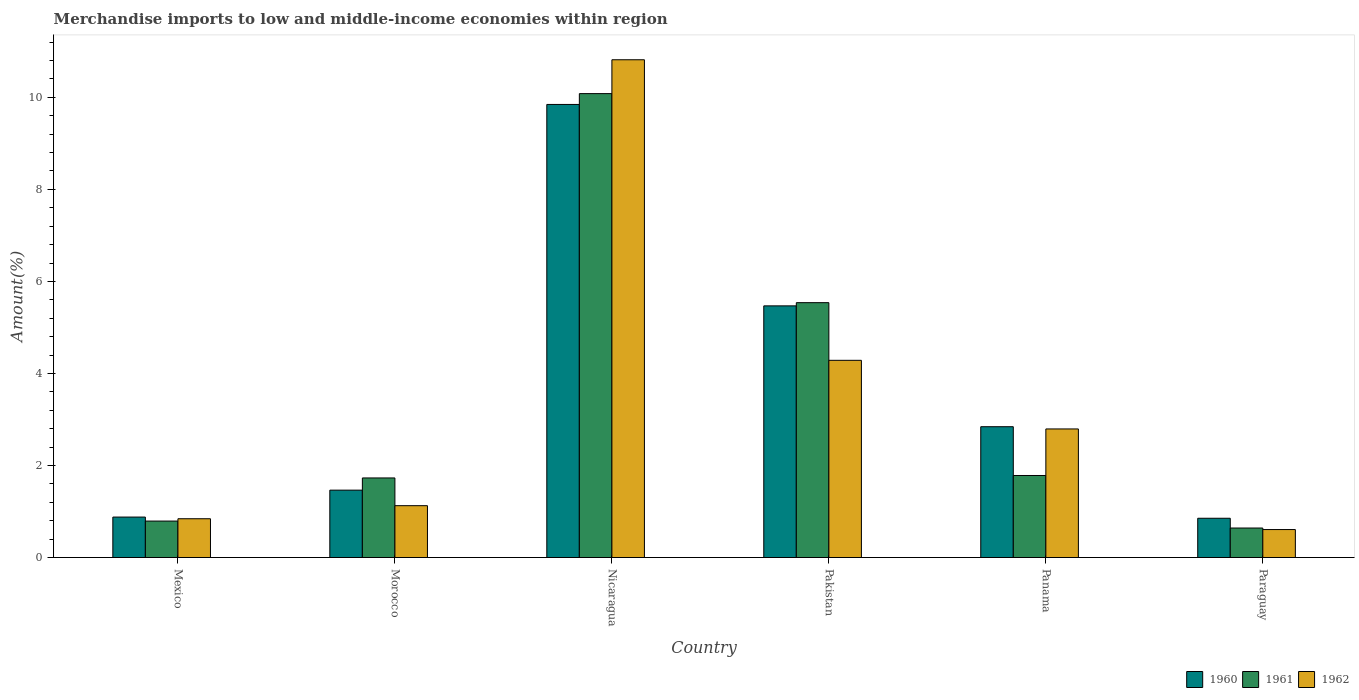How many groups of bars are there?
Provide a succinct answer. 6. Are the number of bars per tick equal to the number of legend labels?
Keep it short and to the point. Yes. How many bars are there on the 3rd tick from the right?
Your answer should be very brief. 3. What is the label of the 5th group of bars from the left?
Keep it short and to the point. Panama. What is the percentage of amount earned from merchandise imports in 1961 in Paraguay?
Your response must be concise. 0.64. Across all countries, what is the maximum percentage of amount earned from merchandise imports in 1960?
Your response must be concise. 9.85. Across all countries, what is the minimum percentage of amount earned from merchandise imports in 1960?
Give a very brief answer. 0.85. In which country was the percentage of amount earned from merchandise imports in 1960 maximum?
Your answer should be very brief. Nicaragua. In which country was the percentage of amount earned from merchandise imports in 1961 minimum?
Provide a short and direct response. Paraguay. What is the total percentage of amount earned from merchandise imports in 1962 in the graph?
Ensure brevity in your answer.  20.47. What is the difference between the percentage of amount earned from merchandise imports in 1962 in Mexico and that in Morocco?
Your answer should be very brief. -0.28. What is the difference between the percentage of amount earned from merchandise imports in 1962 in Morocco and the percentage of amount earned from merchandise imports in 1960 in Pakistan?
Your response must be concise. -4.34. What is the average percentage of amount earned from merchandise imports in 1961 per country?
Provide a succinct answer. 3.43. What is the difference between the percentage of amount earned from merchandise imports of/in 1962 and percentage of amount earned from merchandise imports of/in 1960 in Mexico?
Ensure brevity in your answer.  -0.04. What is the ratio of the percentage of amount earned from merchandise imports in 1960 in Mexico to that in Morocco?
Make the answer very short. 0.6. Is the percentage of amount earned from merchandise imports in 1961 in Nicaragua less than that in Paraguay?
Offer a terse response. No. What is the difference between the highest and the second highest percentage of amount earned from merchandise imports in 1961?
Ensure brevity in your answer.  -8.3. What is the difference between the highest and the lowest percentage of amount earned from merchandise imports in 1961?
Provide a succinct answer. 9.44. Is the sum of the percentage of amount earned from merchandise imports in 1962 in Mexico and Pakistan greater than the maximum percentage of amount earned from merchandise imports in 1961 across all countries?
Provide a short and direct response. No. What does the 3rd bar from the right in Mexico represents?
Make the answer very short. 1960. Are all the bars in the graph horizontal?
Provide a short and direct response. No. How many countries are there in the graph?
Your answer should be compact. 6. What is the difference between two consecutive major ticks on the Y-axis?
Make the answer very short. 2. Are the values on the major ticks of Y-axis written in scientific E-notation?
Keep it short and to the point. No. Does the graph contain grids?
Offer a terse response. No. How are the legend labels stacked?
Offer a very short reply. Horizontal. What is the title of the graph?
Your answer should be very brief. Merchandise imports to low and middle-income economies within region. Does "1967" appear as one of the legend labels in the graph?
Keep it short and to the point. No. What is the label or title of the Y-axis?
Offer a very short reply. Amount(%). What is the Amount(%) of 1960 in Mexico?
Your answer should be very brief. 0.88. What is the Amount(%) in 1961 in Mexico?
Make the answer very short. 0.79. What is the Amount(%) in 1962 in Mexico?
Make the answer very short. 0.84. What is the Amount(%) of 1960 in Morocco?
Make the answer very short. 1.46. What is the Amount(%) in 1961 in Morocco?
Provide a succinct answer. 1.73. What is the Amount(%) in 1962 in Morocco?
Offer a very short reply. 1.13. What is the Amount(%) of 1960 in Nicaragua?
Provide a short and direct response. 9.85. What is the Amount(%) in 1961 in Nicaragua?
Your response must be concise. 10.08. What is the Amount(%) in 1962 in Nicaragua?
Ensure brevity in your answer.  10.82. What is the Amount(%) in 1960 in Pakistan?
Your answer should be compact. 5.47. What is the Amount(%) in 1961 in Pakistan?
Your answer should be very brief. 5.54. What is the Amount(%) of 1962 in Pakistan?
Your answer should be very brief. 4.29. What is the Amount(%) in 1960 in Panama?
Offer a terse response. 2.84. What is the Amount(%) in 1961 in Panama?
Ensure brevity in your answer.  1.78. What is the Amount(%) of 1962 in Panama?
Ensure brevity in your answer.  2.79. What is the Amount(%) in 1960 in Paraguay?
Your answer should be compact. 0.85. What is the Amount(%) of 1961 in Paraguay?
Provide a short and direct response. 0.64. What is the Amount(%) in 1962 in Paraguay?
Your answer should be very brief. 0.61. Across all countries, what is the maximum Amount(%) of 1960?
Provide a short and direct response. 9.85. Across all countries, what is the maximum Amount(%) of 1961?
Provide a short and direct response. 10.08. Across all countries, what is the maximum Amount(%) of 1962?
Your response must be concise. 10.82. Across all countries, what is the minimum Amount(%) in 1960?
Keep it short and to the point. 0.85. Across all countries, what is the minimum Amount(%) in 1961?
Provide a succinct answer. 0.64. Across all countries, what is the minimum Amount(%) of 1962?
Give a very brief answer. 0.61. What is the total Amount(%) in 1960 in the graph?
Offer a terse response. 21.35. What is the total Amount(%) in 1961 in the graph?
Make the answer very short. 20.56. What is the total Amount(%) of 1962 in the graph?
Keep it short and to the point. 20.47. What is the difference between the Amount(%) in 1960 in Mexico and that in Morocco?
Keep it short and to the point. -0.59. What is the difference between the Amount(%) of 1961 in Mexico and that in Morocco?
Your answer should be very brief. -0.94. What is the difference between the Amount(%) in 1962 in Mexico and that in Morocco?
Give a very brief answer. -0.28. What is the difference between the Amount(%) of 1960 in Mexico and that in Nicaragua?
Offer a terse response. -8.97. What is the difference between the Amount(%) in 1961 in Mexico and that in Nicaragua?
Make the answer very short. -9.29. What is the difference between the Amount(%) of 1962 in Mexico and that in Nicaragua?
Your response must be concise. -9.97. What is the difference between the Amount(%) in 1960 in Mexico and that in Pakistan?
Ensure brevity in your answer.  -4.59. What is the difference between the Amount(%) in 1961 in Mexico and that in Pakistan?
Your answer should be very brief. -4.75. What is the difference between the Amount(%) of 1962 in Mexico and that in Pakistan?
Offer a very short reply. -3.44. What is the difference between the Amount(%) in 1960 in Mexico and that in Panama?
Offer a very short reply. -1.96. What is the difference between the Amount(%) in 1961 in Mexico and that in Panama?
Ensure brevity in your answer.  -0.99. What is the difference between the Amount(%) of 1962 in Mexico and that in Panama?
Provide a short and direct response. -1.95. What is the difference between the Amount(%) of 1960 in Mexico and that in Paraguay?
Keep it short and to the point. 0.03. What is the difference between the Amount(%) of 1961 in Mexico and that in Paraguay?
Your answer should be very brief. 0.15. What is the difference between the Amount(%) in 1962 in Mexico and that in Paraguay?
Provide a short and direct response. 0.23. What is the difference between the Amount(%) of 1960 in Morocco and that in Nicaragua?
Keep it short and to the point. -8.38. What is the difference between the Amount(%) of 1961 in Morocco and that in Nicaragua?
Give a very brief answer. -8.35. What is the difference between the Amount(%) in 1962 in Morocco and that in Nicaragua?
Provide a succinct answer. -9.69. What is the difference between the Amount(%) of 1960 in Morocco and that in Pakistan?
Offer a terse response. -4. What is the difference between the Amount(%) in 1961 in Morocco and that in Pakistan?
Your response must be concise. -3.81. What is the difference between the Amount(%) of 1962 in Morocco and that in Pakistan?
Provide a succinct answer. -3.16. What is the difference between the Amount(%) in 1960 in Morocco and that in Panama?
Offer a very short reply. -1.38. What is the difference between the Amount(%) of 1961 in Morocco and that in Panama?
Offer a terse response. -0.05. What is the difference between the Amount(%) in 1962 in Morocco and that in Panama?
Make the answer very short. -1.67. What is the difference between the Amount(%) in 1960 in Morocco and that in Paraguay?
Give a very brief answer. 0.61. What is the difference between the Amount(%) of 1961 in Morocco and that in Paraguay?
Your answer should be very brief. 1.09. What is the difference between the Amount(%) in 1962 in Morocco and that in Paraguay?
Your answer should be very brief. 0.52. What is the difference between the Amount(%) of 1960 in Nicaragua and that in Pakistan?
Keep it short and to the point. 4.38. What is the difference between the Amount(%) in 1961 in Nicaragua and that in Pakistan?
Give a very brief answer. 4.54. What is the difference between the Amount(%) in 1962 in Nicaragua and that in Pakistan?
Offer a terse response. 6.53. What is the difference between the Amount(%) in 1960 in Nicaragua and that in Panama?
Your answer should be very brief. 7. What is the difference between the Amount(%) in 1961 in Nicaragua and that in Panama?
Keep it short and to the point. 8.3. What is the difference between the Amount(%) of 1962 in Nicaragua and that in Panama?
Provide a short and direct response. 8.02. What is the difference between the Amount(%) in 1960 in Nicaragua and that in Paraguay?
Provide a short and direct response. 8.99. What is the difference between the Amount(%) in 1961 in Nicaragua and that in Paraguay?
Make the answer very short. 9.44. What is the difference between the Amount(%) in 1962 in Nicaragua and that in Paraguay?
Give a very brief answer. 10.21. What is the difference between the Amount(%) of 1960 in Pakistan and that in Panama?
Provide a short and direct response. 2.63. What is the difference between the Amount(%) of 1961 in Pakistan and that in Panama?
Your answer should be very brief. 3.76. What is the difference between the Amount(%) in 1962 in Pakistan and that in Panama?
Your response must be concise. 1.49. What is the difference between the Amount(%) in 1960 in Pakistan and that in Paraguay?
Your answer should be very brief. 4.62. What is the difference between the Amount(%) of 1961 in Pakistan and that in Paraguay?
Provide a succinct answer. 4.9. What is the difference between the Amount(%) of 1962 in Pakistan and that in Paraguay?
Keep it short and to the point. 3.68. What is the difference between the Amount(%) of 1960 in Panama and that in Paraguay?
Keep it short and to the point. 1.99. What is the difference between the Amount(%) in 1961 in Panama and that in Paraguay?
Keep it short and to the point. 1.14. What is the difference between the Amount(%) of 1962 in Panama and that in Paraguay?
Provide a succinct answer. 2.19. What is the difference between the Amount(%) of 1960 in Mexico and the Amount(%) of 1961 in Morocco?
Your answer should be compact. -0.85. What is the difference between the Amount(%) of 1960 in Mexico and the Amount(%) of 1962 in Morocco?
Give a very brief answer. -0.25. What is the difference between the Amount(%) of 1961 in Mexico and the Amount(%) of 1962 in Morocco?
Ensure brevity in your answer.  -0.33. What is the difference between the Amount(%) in 1960 in Mexico and the Amount(%) in 1961 in Nicaragua?
Ensure brevity in your answer.  -9.2. What is the difference between the Amount(%) of 1960 in Mexico and the Amount(%) of 1962 in Nicaragua?
Make the answer very short. -9.94. What is the difference between the Amount(%) of 1961 in Mexico and the Amount(%) of 1962 in Nicaragua?
Keep it short and to the point. -10.02. What is the difference between the Amount(%) of 1960 in Mexico and the Amount(%) of 1961 in Pakistan?
Ensure brevity in your answer.  -4.66. What is the difference between the Amount(%) of 1960 in Mexico and the Amount(%) of 1962 in Pakistan?
Make the answer very short. -3.41. What is the difference between the Amount(%) in 1961 in Mexico and the Amount(%) in 1962 in Pakistan?
Offer a very short reply. -3.49. What is the difference between the Amount(%) in 1960 in Mexico and the Amount(%) in 1961 in Panama?
Offer a terse response. -0.9. What is the difference between the Amount(%) of 1960 in Mexico and the Amount(%) of 1962 in Panama?
Your response must be concise. -1.92. What is the difference between the Amount(%) in 1961 in Mexico and the Amount(%) in 1962 in Panama?
Your response must be concise. -2. What is the difference between the Amount(%) of 1960 in Mexico and the Amount(%) of 1961 in Paraguay?
Offer a terse response. 0.24. What is the difference between the Amount(%) in 1960 in Mexico and the Amount(%) in 1962 in Paraguay?
Give a very brief answer. 0.27. What is the difference between the Amount(%) in 1961 in Mexico and the Amount(%) in 1962 in Paraguay?
Give a very brief answer. 0.18. What is the difference between the Amount(%) in 1960 in Morocco and the Amount(%) in 1961 in Nicaragua?
Your response must be concise. -8.62. What is the difference between the Amount(%) in 1960 in Morocco and the Amount(%) in 1962 in Nicaragua?
Give a very brief answer. -9.35. What is the difference between the Amount(%) in 1961 in Morocco and the Amount(%) in 1962 in Nicaragua?
Offer a very short reply. -9.09. What is the difference between the Amount(%) of 1960 in Morocco and the Amount(%) of 1961 in Pakistan?
Ensure brevity in your answer.  -4.07. What is the difference between the Amount(%) of 1960 in Morocco and the Amount(%) of 1962 in Pakistan?
Offer a terse response. -2.82. What is the difference between the Amount(%) in 1961 in Morocco and the Amount(%) in 1962 in Pakistan?
Make the answer very short. -2.56. What is the difference between the Amount(%) in 1960 in Morocco and the Amount(%) in 1961 in Panama?
Your response must be concise. -0.32. What is the difference between the Amount(%) of 1960 in Morocco and the Amount(%) of 1962 in Panama?
Offer a terse response. -1.33. What is the difference between the Amount(%) in 1961 in Morocco and the Amount(%) in 1962 in Panama?
Give a very brief answer. -1.06. What is the difference between the Amount(%) in 1960 in Morocco and the Amount(%) in 1961 in Paraguay?
Your answer should be compact. 0.82. What is the difference between the Amount(%) of 1960 in Morocco and the Amount(%) of 1962 in Paraguay?
Offer a terse response. 0.86. What is the difference between the Amount(%) in 1961 in Morocco and the Amount(%) in 1962 in Paraguay?
Provide a succinct answer. 1.12. What is the difference between the Amount(%) in 1960 in Nicaragua and the Amount(%) in 1961 in Pakistan?
Ensure brevity in your answer.  4.31. What is the difference between the Amount(%) of 1960 in Nicaragua and the Amount(%) of 1962 in Pakistan?
Provide a short and direct response. 5.56. What is the difference between the Amount(%) of 1961 in Nicaragua and the Amount(%) of 1962 in Pakistan?
Keep it short and to the point. 5.8. What is the difference between the Amount(%) in 1960 in Nicaragua and the Amount(%) in 1961 in Panama?
Keep it short and to the point. 8.06. What is the difference between the Amount(%) of 1960 in Nicaragua and the Amount(%) of 1962 in Panama?
Provide a short and direct response. 7.05. What is the difference between the Amount(%) of 1961 in Nicaragua and the Amount(%) of 1962 in Panama?
Offer a very short reply. 7.29. What is the difference between the Amount(%) of 1960 in Nicaragua and the Amount(%) of 1961 in Paraguay?
Offer a very short reply. 9.2. What is the difference between the Amount(%) of 1960 in Nicaragua and the Amount(%) of 1962 in Paraguay?
Provide a short and direct response. 9.24. What is the difference between the Amount(%) of 1961 in Nicaragua and the Amount(%) of 1962 in Paraguay?
Give a very brief answer. 9.47. What is the difference between the Amount(%) of 1960 in Pakistan and the Amount(%) of 1961 in Panama?
Provide a short and direct response. 3.69. What is the difference between the Amount(%) in 1960 in Pakistan and the Amount(%) in 1962 in Panama?
Your answer should be compact. 2.67. What is the difference between the Amount(%) of 1961 in Pakistan and the Amount(%) of 1962 in Panama?
Offer a very short reply. 2.74. What is the difference between the Amount(%) of 1960 in Pakistan and the Amount(%) of 1961 in Paraguay?
Offer a terse response. 4.83. What is the difference between the Amount(%) in 1960 in Pakistan and the Amount(%) in 1962 in Paraguay?
Provide a succinct answer. 4.86. What is the difference between the Amount(%) in 1961 in Pakistan and the Amount(%) in 1962 in Paraguay?
Your response must be concise. 4.93. What is the difference between the Amount(%) in 1960 in Panama and the Amount(%) in 1961 in Paraguay?
Provide a short and direct response. 2.2. What is the difference between the Amount(%) in 1960 in Panama and the Amount(%) in 1962 in Paraguay?
Your answer should be very brief. 2.23. What is the difference between the Amount(%) of 1961 in Panama and the Amount(%) of 1962 in Paraguay?
Make the answer very short. 1.17. What is the average Amount(%) of 1960 per country?
Provide a succinct answer. 3.56. What is the average Amount(%) in 1961 per country?
Your answer should be very brief. 3.43. What is the average Amount(%) in 1962 per country?
Provide a short and direct response. 3.41. What is the difference between the Amount(%) in 1960 and Amount(%) in 1961 in Mexico?
Give a very brief answer. 0.09. What is the difference between the Amount(%) in 1960 and Amount(%) in 1962 in Mexico?
Your answer should be very brief. 0.04. What is the difference between the Amount(%) of 1961 and Amount(%) of 1962 in Mexico?
Keep it short and to the point. -0.05. What is the difference between the Amount(%) of 1960 and Amount(%) of 1961 in Morocco?
Your answer should be very brief. -0.27. What is the difference between the Amount(%) in 1960 and Amount(%) in 1962 in Morocco?
Offer a terse response. 0.34. What is the difference between the Amount(%) in 1961 and Amount(%) in 1962 in Morocco?
Offer a very short reply. 0.6. What is the difference between the Amount(%) of 1960 and Amount(%) of 1961 in Nicaragua?
Offer a very short reply. -0.24. What is the difference between the Amount(%) of 1960 and Amount(%) of 1962 in Nicaragua?
Provide a succinct answer. -0.97. What is the difference between the Amount(%) of 1961 and Amount(%) of 1962 in Nicaragua?
Provide a succinct answer. -0.74. What is the difference between the Amount(%) of 1960 and Amount(%) of 1961 in Pakistan?
Your answer should be compact. -0.07. What is the difference between the Amount(%) of 1960 and Amount(%) of 1962 in Pakistan?
Your answer should be compact. 1.18. What is the difference between the Amount(%) of 1961 and Amount(%) of 1962 in Pakistan?
Provide a short and direct response. 1.25. What is the difference between the Amount(%) in 1960 and Amount(%) in 1961 in Panama?
Your response must be concise. 1.06. What is the difference between the Amount(%) of 1960 and Amount(%) of 1962 in Panama?
Your response must be concise. 0.05. What is the difference between the Amount(%) in 1961 and Amount(%) in 1962 in Panama?
Give a very brief answer. -1.01. What is the difference between the Amount(%) of 1960 and Amount(%) of 1961 in Paraguay?
Keep it short and to the point. 0.21. What is the difference between the Amount(%) of 1960 and Amount(%) of 1962 in Paraguay?
Provide a succinct answer. 0.25. What is the difference between the Amount(%) of 1961 and Amount(%) of 1962 in Paraguay?
Your response must be concise. 0.03. What is the ratio of the Amount(%) in 1960 in Mexico to that in Morocco?
Your answer should be very brief. 0.6. What is the ratio of the Amount(%) in 1961 in Mexico to that in Morocco?
Your answer should be very brief. 0.46. What is the ratio of the Amount(%) in 1962 in Mexico to that in Morocco?
Ensure brevity in your answer.  0.75. What is the ratio of the Amount(%) of 1960 in Mexico to that in Nicaragua?
Your response must be concise. 0.09. What is the ratio of the Amount(%) in 1961 in Mexico to that in Nicaragua?
Offer a terse response. 0.08. What is the ratio of the Amount(%) in 1962 in Mexico to that in Nicaragua?
Offer a terse response. 0.08. What is the ratio of the Amount(%) of 1960 in Mexico to that in Pakistan?
Ensure brevity in your answer.  0.16. What is the ratio of the Amount(%) of 1961 in Mexico to that in Pakistan?
Give a very brief answer. 0.14. What is the ratio of the Amount(%) of 1962 in Mexico to that in Pakistan?
Offer a very short reply. 0.2. What is the ratio of the Amount(%) in 1960 in Mexico to that in Panama?
Keep it short and to the point. 0.31. What is the ratio of the Amount(%) of 1961 in Mexico to that in Panama?
Your response must be concise. 0.44. What is the ratio of the Amount(%) in 1962 in Mexico to that in Panama?
Provide a short and direct response. 0.3. What is the ratio of the Amount(%) in 1960 in Mexico to that in Paraguay?
Your answer should be very brief. 1.03. What is the ratio of the Amount(%) in 1961 in Mexico to that in Paraguay?
Ensure brevity in your answer.  1.24. What is the ratio of the Amount(%) in 1962 in Mexico to that in Paraguay?
Your response must be concise. 1.39. What is the ratio of the Amount(%) of 1960 in Morocco to that in Nicaragua?
Ensure brevity in your answer.  0.15. What is the ratio of the Amount(%) of 1961 in Morocco to that in Nicaragua?
Your answer should be very brief. 0.17. What is the ratio of the Amount(%) in 1962 in Morocco to that in Nicaragua?
Give a very brief answer. 0.1. What is the ratio of the Amount(%) in 1960 in Morocco to that in Pakistan?
Your answer should be compact. 0.27. What is the ratio of the Amount(%) in 1961 in Morocco to that in Pakistan?
Offer a terse response. 0.31. What is the ratio of the Amount(%) in 1962 in Morocco to that in Pakistan?
Offer a very short reply. 0.26. What is the ratio of the Amount(%) of 1960 in Morocco to that in Panama?
Provide a short and direct response. 0.52. What is the ratio of the Amount(%) of 1961 in Morocco to that in Panama?
Your response must be concise. 0.97. What is the ratio of the Amount(%) of 1962 in Morocco to that in Panama?
Your answer should be very brief. 0.4. What is the ratio of the Amount(%) in 1960 in Morocco to that in Paraguay?
Provide a short and direct response. 1.72. What is the ratio of the Amount(%) in 1961 in Morocco to that in Paraguay?
Your answer should be very brief. 2.7. What is the ratio of the Amount(%) in 1962 in Morocco to that in Paraguay?
Give a very brief answer. 1.85. What is the ratio of the Amount(%) in 1960 in Nicaragua to that in Pakistan?
Offer a terse response. 1.8. What is the ratio of the Amount(%) in 1961 in Nicaragua to that in Pakistan?
Ensure brevity in your answer.  1.82. What is the ratio of the Amount(%) in 1962 in Nicaragua to that in Pakistan?
Provide a short and direct response. 2.52. What is the ratio of the Amount(%) in 1960 in Nicaragua to that in Panama?
Provide a succinct answer. 3.46. What is the ratio of the Amount(%) of 1961 in Nicaragua to that in Panama?
Your answer should be compact. 5.66. What is the ratio of the Amount(%) in 1962 in Nicaragua to that in Panama?
Offer a terse response. 3.87. What is the ratio of the Amount(%) in 1960 in Nicaragua to that in Paraguay?
Provide a succinct answer. 11.54. What is the ratio of the Amount(%) in 1961 in Nicaragua to that in Paraguay?
Provide a short and direct response. 15.72. What is the ratio of the Amount(%) in 1962 in Nicaragua to that in Paraguay?
Provide a short and direct response. 17.8. What is the ratio of the Amount(%) in 1960 in Pakistan to that in Panama?
Offer a very short reply. 1.92. What is the ratio of the Amount(%) of 1961 in Pakistan to that in Panama?
Your answer should be very brief. 3.11. What is the ratio of the Amount(%) in 1962 in Pakistan to that in Panama?
Your answer should be very brief. 1.53. What is the ratio of the Amount(%) of 1960 in Pakistan to that in Paraguay?
Offer a terse response. 6.41. What is the ratio of the Amount(%) in 1961 in Pakistan to that in Paraguay?
Your answer should be compact. 8.64. What is the ratio of the Amount(%) of 1962 in Pakistan to that in Paraguay?
Your answer should be compact. 7.05. What is the ratio of the Amount(%) in 1960 in Panama to that in Paraguay?
Provide a short and direct response. 3.33. What is the ratio of the Amount(%) of 1961 in Panama to that in Paraguay?
Provide a succinct answer. 2.78. What is the ratio of the Amount(%) of 1962 in Panama to that in Paraguay?
Provide a short and direct response. 4.6. What is the difference between the highest and the second highest Amount(%) in 1960?
Your answer should be compact. 4.38. What is the difference between the highest and the second highest Amount(%) of 1961?
Your answer should be very brief. 4.54. What is the difference between the highest and the second highest Amount(%) of 1962?
Offer a very short reply. 6.53. What is the difference between the highest and the lowest Amount(%) in 1960?
Give a very brief answer. 8.99. What is the difference between the highest and the lowest Amount(%) of 1961?
Offer a very short reply. 9.44. What is the difference between the highest and the lowest Amount(%) in 1962?
Keep it short and to the point. 10.21. 